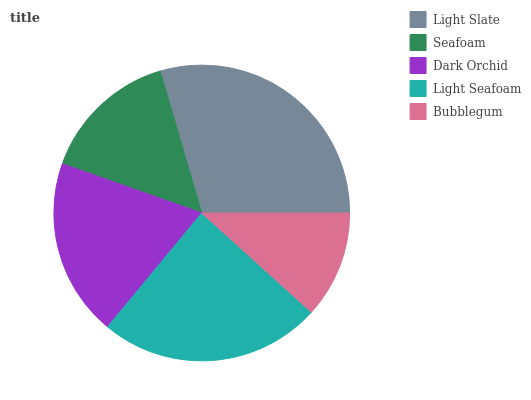Is Bubblegum the minimum?
Answer yes or no. Yes. Is Light Slate the maximum?
Answer yes or no. Yes. Is Seafoam the minimum?
Answer yes or no. No. Is Seafoam the maximum?
Answer yes or no. No. Is Light Slate greater than Seafoam?
Answer yes or no. Yes. Is Seafoam less than Light Slate?
Answer yes or no. Yes. Is Seafoam greater than Light Slate?
Answer yes or no. No. Is Light Slate less than Seafoam?
Answer yes or no. No. Is Dark Orchid the high median?
Answer yes or no. Yes. Is Dark Orchid the low median?
Answer yes or no. Yes. Is Seafoam the high median?
Answer yes or no. No. Is Bubblegum the low median?
Answer yes or no. No. 